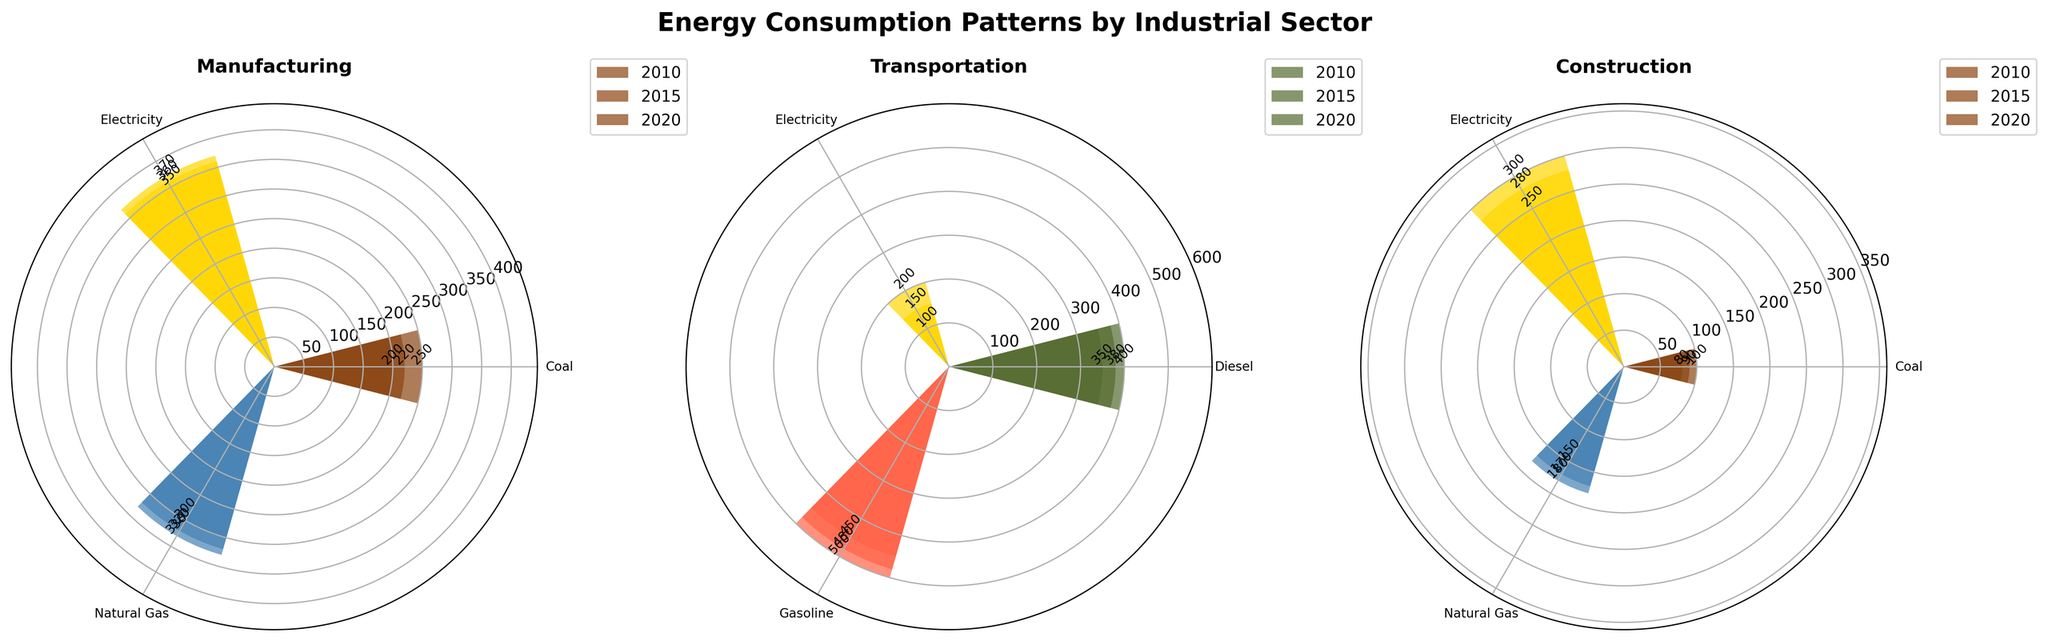What is the title of the figure? The title is usually found at the top of the chart and is meant to provide a summary of what the figure represents. Here, the title "Energy Consumption Patterns by Industrial Sector" is prominently displayed at the top.
Answer: Energy Consumption Patterns by Industrial Sector Which year has the highest electricity consumption in the Transportation sector? For the Transportation sector, examine the electric consumption bars across different years. Compare bar heights for each year to identify the highest one. 2020's bar is the tallest, indicating the highest consumption.
Answer: 2020 How does natural gas consumption in the Manufacturing sector change from 2010 to 2020? Look at the Manufacturing sector and compare the heights of the bars corresponding to natural gas for the years 2010, 2015, and 2020. In 2010, it's around 300 units, and by 2020, it has increased to about 330 units.
Answer: It increases Which sector shows a decrease in coal consumption from 2010 to 2020? Compare the heights of the coal consumption bars for 2010 and 2020 for each sector. Both Manufacturing and Construction show a significant decrease, but Transportation does not use coal.
Answer: Manufacturing and Construction What is the total electricity consumption for the Construction sector over the years 2010, 2015, and 2020? Sum the heights of the electricity bars for Construction in each year. For 2010, 2015, and 2020, the values are around 250, 280, and 300 units respectively. Therefore, add 250 + 280 + 300.
Answer: 830 Which sector shows the most diverse energy consumption types? Evaluate the number of different energy source bars shown for each sector. Manufacturing and Construction have three types (Coal, Natural Gas, Electricity), whereas Transportation has three (Diesel, Gasoline, Electricity). Each has the same number, so we'll say they equally diverse.
Answer: Manufacturing and Construction What is the trend observed in diesel consumption for the Transportation sector? Compare the heights of the diesel bars in the Transportation sector across 2010, 2015, and 2020. The heights show a continuous decrease from 400 units in 2010 to 350 units in 2020.
Answer: Decreasing Which year has the most total energy consumption for the Manufacturing sector? To find this, add up the heights of all the bars (across all energy types) for each year in the Manufacturing sector, then compare. Total for 2010 is 900 (250+300+350), 2015 is 900 (220+320+360), and 2020 is 900 (200+330+370). Thus, they are equal.
Answer: All years are equal 